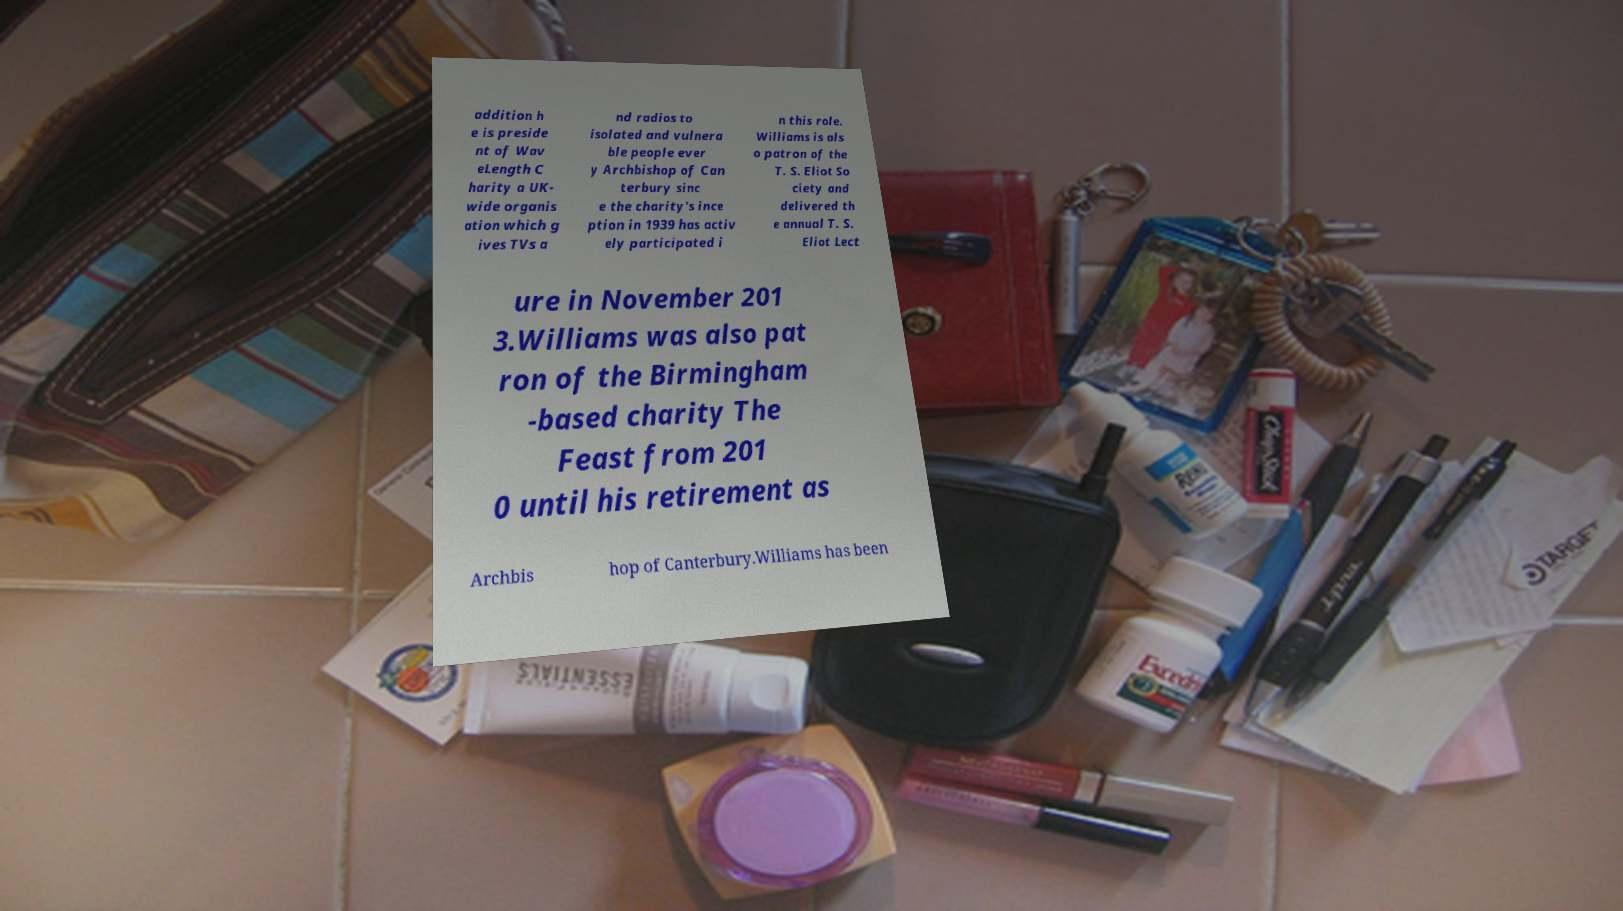For documentation purposes, I need the text within this image transcribed. Could you provide that? addition h e is preside nt of Wav eLength C harity a UK- wide organis ation which g ives TVs a nd radios to isolated and vulnera ble people ever y Archbishop of Can terbury sinc e the charity's ince ption in 1939 has activ ely participated i n this role. Williams is als o patron of the T. S. Eliot So ciety and delivered th e annual T. S. Eliot Lect ure in November 201 3.Williams was also pat ron of the Birmingham -based charity The Feast from 201 0 until his retirement as Archbis hop of Canterbury.Williams has been 